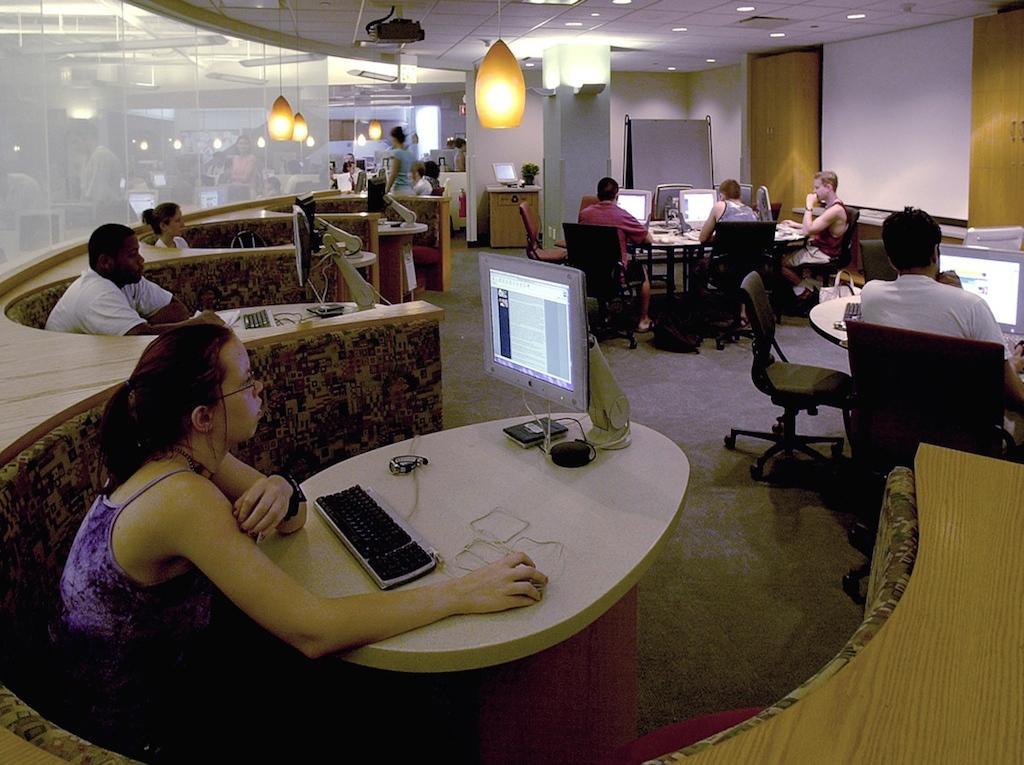In one or two sentences, can you explain what this image depicts? In this picture I can see few monitors, keyboards on the tables and I can see a mouse and few people sitting and working. I can see few lights to the ceiling and a woman standing in the back. 